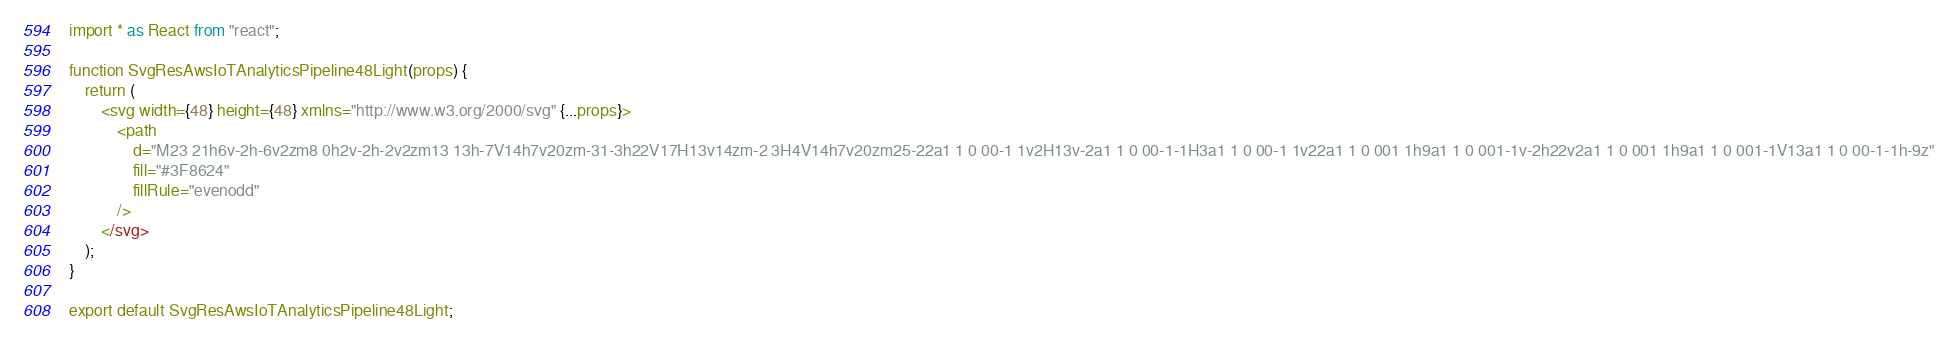Convert code to text. <code><loc_0><loc_0><loc_500><loc_500><_JavaScript_>import * as React from "react";

function SvgResAwsIoTAnalyticsPipeline48Light(props) {
	return (
		<svg width={48} height={48} xmlns="http://www.w3.org/2000/svg" {...props}>
			<path
				d="M23 21h6v-2h-6v2zm8 0h2v-2h-2v2zm13 13h-7V14h7v20zm-31-3h22V17H13v14zm-2 3H4V14h7v20zm25-22a1 1 0 00-1 1v2H13v-2a1 1 0 00-1-1H3a1 1 0 00-1 1v22a1 1 0 001 1h9a1 1 0 001-1v-2h22v2a1 1 0 001 1h9a1 1 0 001-1V13a1 1 0 00-1-1h-9z"
				fill="#3F8624"
				fillRule="evenodd"
			/>
		</svg>
	);
}

export default SvgResAwsIoTAnalyticsPipeline48Light;
</code> 